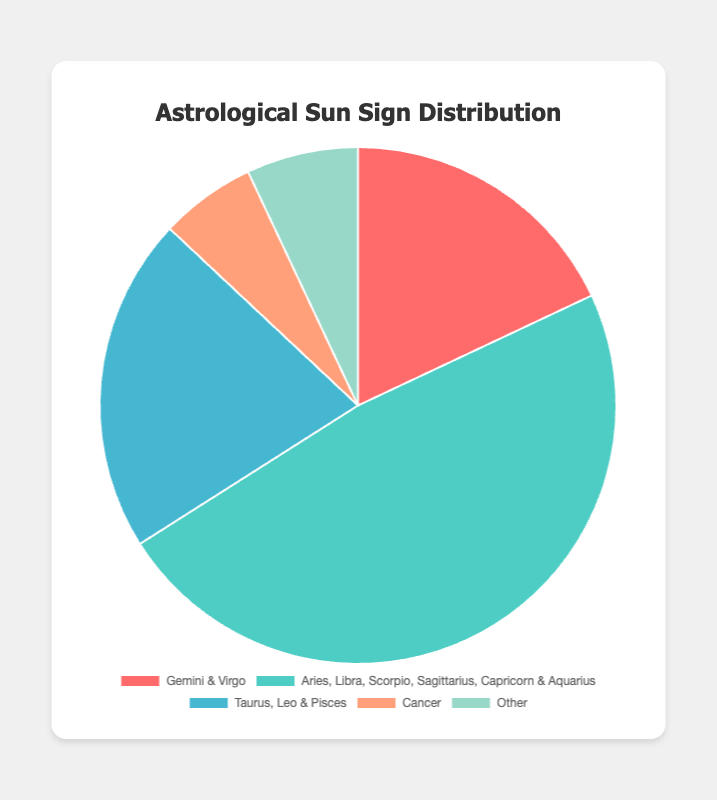What percentage of the population has either Gemini or Virgo as their sun sign? Gemini and Virgo have combined percentage of 18% as shown in the chart. Each contributes 9%, making a sum of 18%.
Answer: 18% How does the percentage of people with Cancer sun sign compare to those with Gemini sun sign? Cancer has a 6% share while Gemini contributes 9% in the distribution. Gemini's percentage is higher than Cancer's.
Answer: Gemini has 3% more than Cancer Which sun sign category has the highest representation and what is that percentage? The groups 'Aries, Libra, Scorpio, Sagittarius, Capricorn & Aquarius' together form the highest category with a combined 48%.
Answer: 'Aries, Libra, Scorpio, Sagittarius, Capricorn & Aquarius' at 48% What is the combined percentage of people with Taurus, Leo, and Pisces sun signs? Taurus, Leo, and Pisces each represent 7%. Combined together, they sum up to 21%.
Answer: 21% What is the difference in percentage representation between the least represented sun sign and the most represented group? The least represented is Cancer with 6%. The most represented group is 'Aries, Libra, Scorpio, Sagittarius, Capricorn & Aquarius' with 48%. The difference is 48% - 6% = 42%.
Answer: 42% Which color represents Cancer in the pie chart? The color representing Cancer in the chart is a distinct shade, denoted by '#FFA07A', which corresponds to a light salmon color.
Answer: Light Salmon How many percentage points more are there for Gemini and Virgo together compared to the "Other" category? Gemini and Virgo together have 18%. The 'Other' category has 7%. The difference is 18% - 7% = 11%.
Answer: 11% If you combine the representation of Aries, Libra, and Scorpio, what percentage do they account for? Aries, Libra, and Scorpio each represent 8%. Combined, they sum up to 8% + 8% + 8% = 24%.
Answer: 24% What's the combined percentage of the sun signs Aries, Libra, Scorpio, Sagittarius, Capricorn, and Aquarius? These sun signs collectively account for 8%, and there are six in total. So, 8% * 6 = 48%.
Answer: 48% What is the percentage representation for Leo and how does it compare visually in terms of color? Leo has 7%. The color representing Leo in the chart is '#4ECDC4,' which corresponds to a soft teal color.
Answer: 7%, Soft Teal 